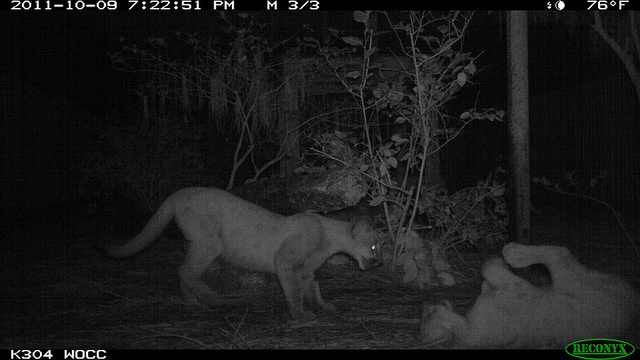Describe the objects in this image and their specific colors. I can see cat in black, green, and darkgreen tones and cat in black, gray, darkgray, and white tones in this image. 